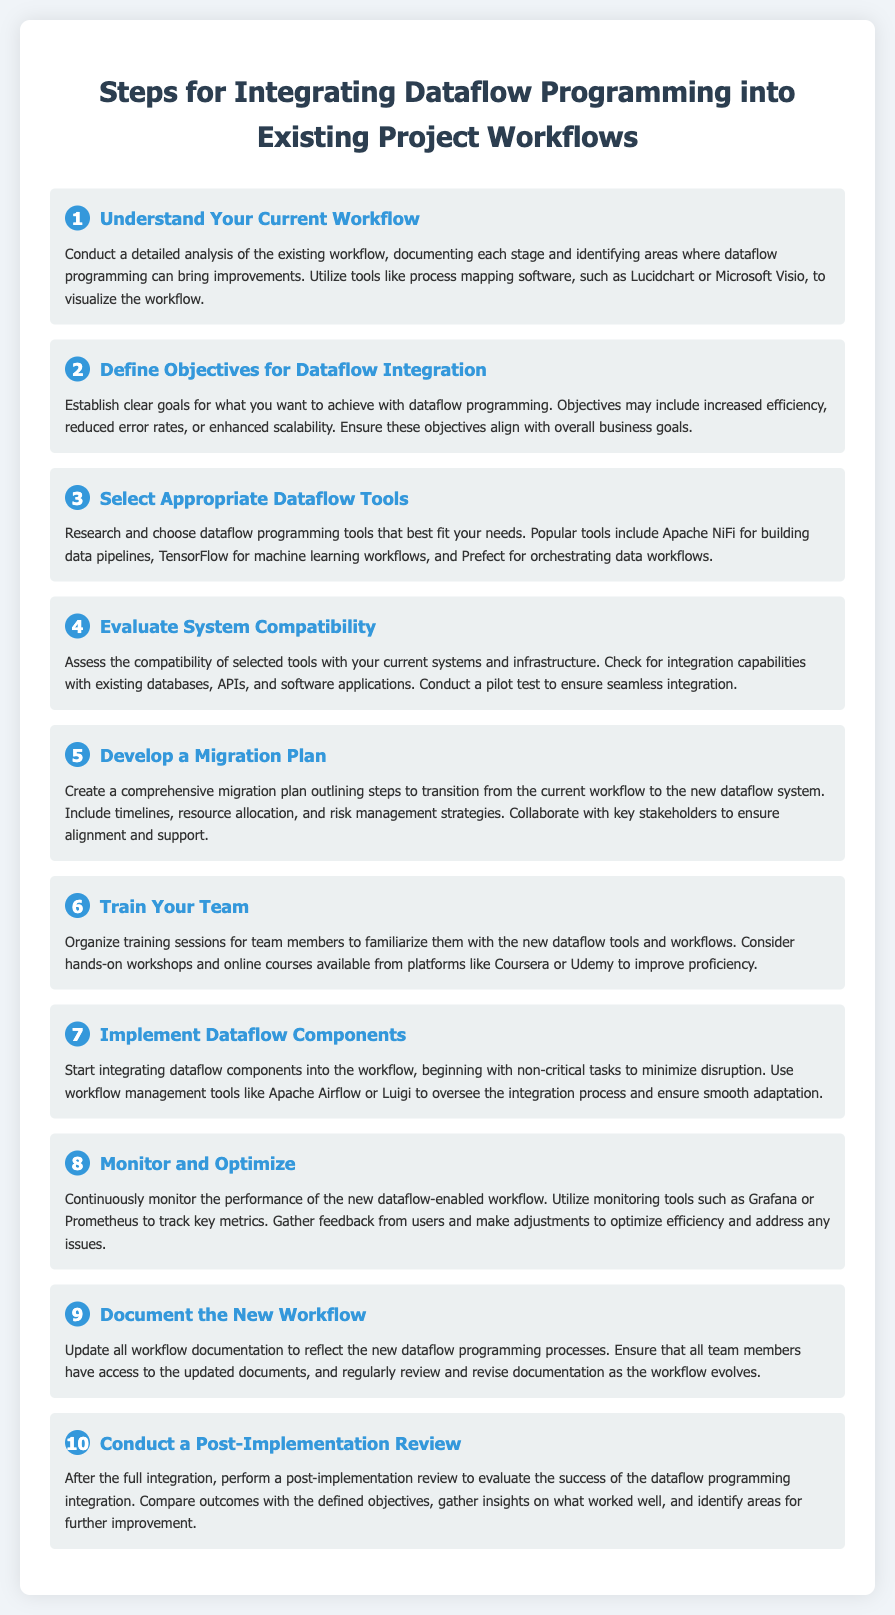What is the first step in integrating dataflow programming? The first step is to conduct a detailed analysis of the existing workflow and document each stage.
Answer: Understand Your Current Workflow How many steps are in the dataflow programming integration checklist? The checklist contains ten steps that outline the integration process.
Answer: 10 What is the objective of defining objectives for dataflow integration? The objective is to establish clear goals for what you want to achieve with dataflow programming.
Answer: Clear goals Which tool is suggested for building data pipelines? Apache NiFi is mentioned as a tool for building data pipelines.
Answer: Apache NiFi What should be included in the comprehensive migration plan? The migration plan should outline steps, timelines, resource allocation, and risk management strategies.
Answer: Comprehensive migration plan What is the purpose of monitoring tools like Grafana or Prometheus? The purpose is to track key metrics of the new dataflow-enabled workflow.
Answer: Track key metrics In which step should team training sessions be organized? Training sessions should be organized in step six of the checklist.
Answer: Step 6 What is the last step in the integration process? The last step involves conducting a post-implementation review to evaluate the integration success.
Answer: Conduct a Post-Implementation Review 